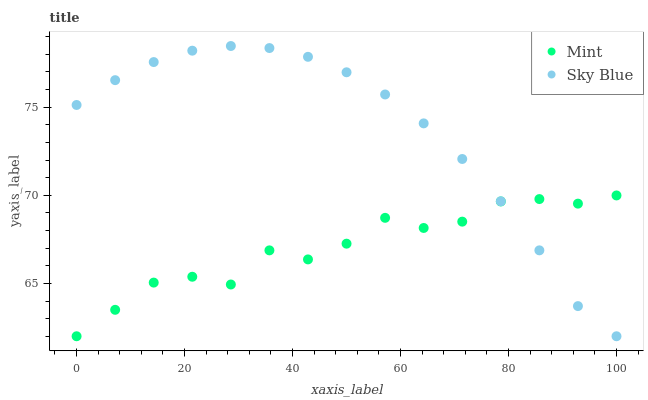Does Mint have the minimum area under the curve?
Answer yes or no. Yes. Does Sky Blue have the maximum area under the curve?
Answer yes or no. Yes. Does Mint have the maximum area under the curve?
Answer yes or no. No. Is Sky Blue the smoothest?
Answer yes or no. Yes. Is Mint the roughest?
Answer yes or no. Yes. Is Mint the smoothest?
Answer yes or no. No. Does Sky Blue have the lowest value?
Answer yes or no. Yes. Does Sky Blue have the highest value?
Answer yes or no. Yes. Does Mint have the highest value?
Answer yes or no. No. Does Sky Blue intersect Mint?
Answer yes or no. Yes. Is Sky Blue less than Mint?
Answer yes or no. No. Is Sky Blue greater than Mint?
Answer yes or no. No. 